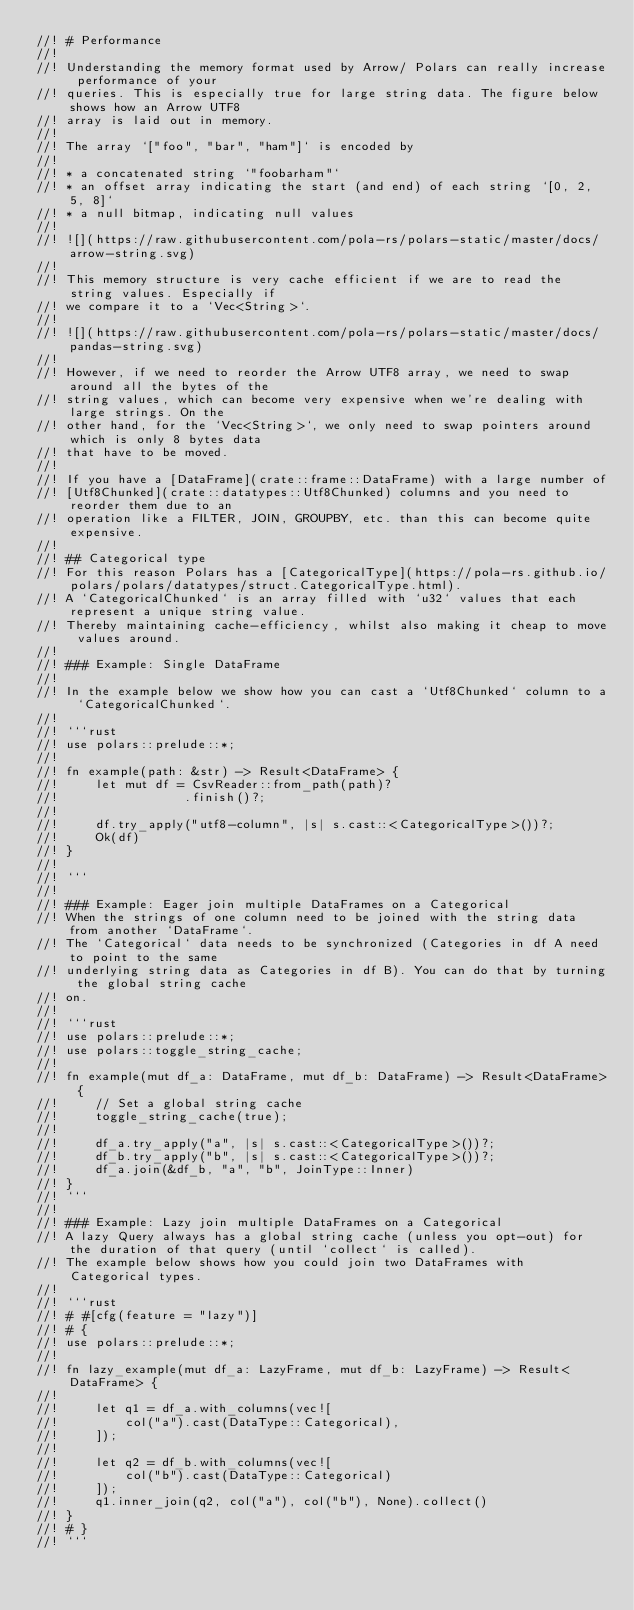<code> <loc_0><loc_0><loc_500><loc_500><_Rust_>//! # Performance
//!
//! Understanding the memory format used by Arrow/ Polars can really increase performance of your
//! queries. This is especially true for large string data. The figure below shows how an Arrow UTF8
//! array is laid out in memory.
//!
//! The array `["foo", "bar", "ham"]` is encoded by
//!
//! * a concatenated string `"foobarham"`
//! * an offset array indicating the start (and end) of each string `[0, 2, 5, 8]`
//! * a null bitmap, indicating null values
//!
//! ![](https://raw.githubusercontent.com/pola-rs/polars-static/master/docs/arrow-string.svg)
//!
//! This memory structure is very cache efficient if we are to read the string values. Especially if
//! we compare it to a `Vec<String>`.
//!
//! ![](https://raw.githubusercontent.com/pola-rs/polars-static/master/docs/pandas-string.svg)
//!
//! However, if we need to reorder the Arrow UTF8 array, we need to swap around all the bytes of the
//! string values, which can become very expensive when we're dealing with large strings. On the
//! other hand, for the `Vec<String>`, we only need to swap pointers around which is only 8 bytes data
//! that have to be moved.
//!
//! If you have a [DataFrame](crate::frame::DataFrame) with a large number of
//! [Utf8Chunked](crate::datatypes::Utf8Chunked) columns and you need to reorder them due to an
//! operation like a FILTER, JOIN, GROUPBY, etc. than this can become quite expensive.
//!
//! ## Categorical type
//! For this reason Polars has a [CategoricalType](https://pola-rs.github.io/polars/polars/datatypes/struct.CategoricalType.html).
//! A `CategoricalChunked` is an array filled with `u32` values that each represent a unique string value.
//! Thereby maintaining cache-efficiency, whilst also making it cheap to move values around.
//!
//! ### Example: Single DataFrame
//!
//! In the example below we show how you can cast a `Utf8Chunked` column to a `CategoricalChunked`.
//!
//! ```rust
//! use polars::prelude::*;
//!
//! fn example(path: &str) -> Result<DataFrame> {
//!     let mut df = CsvReader::from_path(path)?
//!                 .finish()?;
//!
//!     df.try_apply("utf8-column", |s| s.cast::<CategoricalType>())?;
//!     Ok(df)
//! }
//!
//! ```
//!
//! ### Example: Eager join multiple DataFrames on a Categorical
//! When the strings of one column need to be joined with the string data from another `DataFrame`.
//! The `Categorical` data needs to be synchronized (Categories in df A need to point to the same
//! underlying string data as Categories in df B). You can do that by turning the global string cache
//! on.
//!
//! ```rust
//! use polars::prelude::*;
//! use polars::toggle_string_cache;
//!
//! fn example(mut df_a: DataFrame, mut df_b: DataFrame) -> Result<DataFrame> {
//!     // Set a global string cache
//!     toggle_string_cache(true);
//!
//!     df_a.try_apply("a", |s| s.cast::<CategoricalType>())?;
//!     df_b.try_apply("b", |s| s.cast::<CategoricalType>())?;
//!     df_a.join(&df_b, "a", "b", JoinType::Inner)
//! }
//! ```
//!
//! ### Example: Lazy join multiple DataFrames on a Categorical
//! A lazy Query always has a global string cache (unless you opt-out) for the duration of that query (until `collect` is called).
//! The example below shows how you could join two DataFrames with Categorical types.
//!
//! ```rust
//! # #[cfg(feature = "lazy")]
//! # {
//! use polars::prelude::*;
//!
//! fn lazy_example(mut df_a: LazyFrame, mut df_b: LazyFrame) -> Result<DataFrame> {
//!
//!     let q1 = df_a.with_columns(vec![
//!         col("a").cast(DataType::Categorical),
//!     ]);
//!
//!     let q2 = df_b.with_columns(vec![
//!         col("b").cast(DataType::Categorical)
//!     ]);
//!     q1.inner_join(q2, col("a"), col("b"), None).collect()
//! }
//! # }
//! ```
</code> 